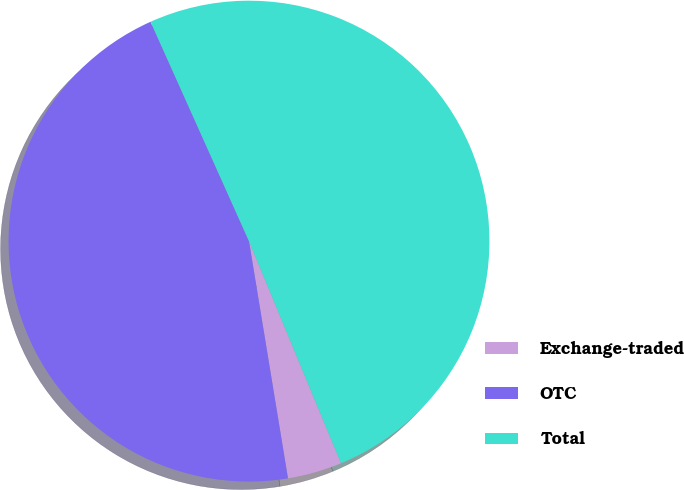Convert chart to OTSL. <chart><loc_0><loc_0><loc_500><loc_500><pie_chart><fcel>Exchange-traded<fcel>OTC<fcel>Total<nl><fcel>3.66%<fcel>45.88%<fcel>50.46%<nl></chart> 